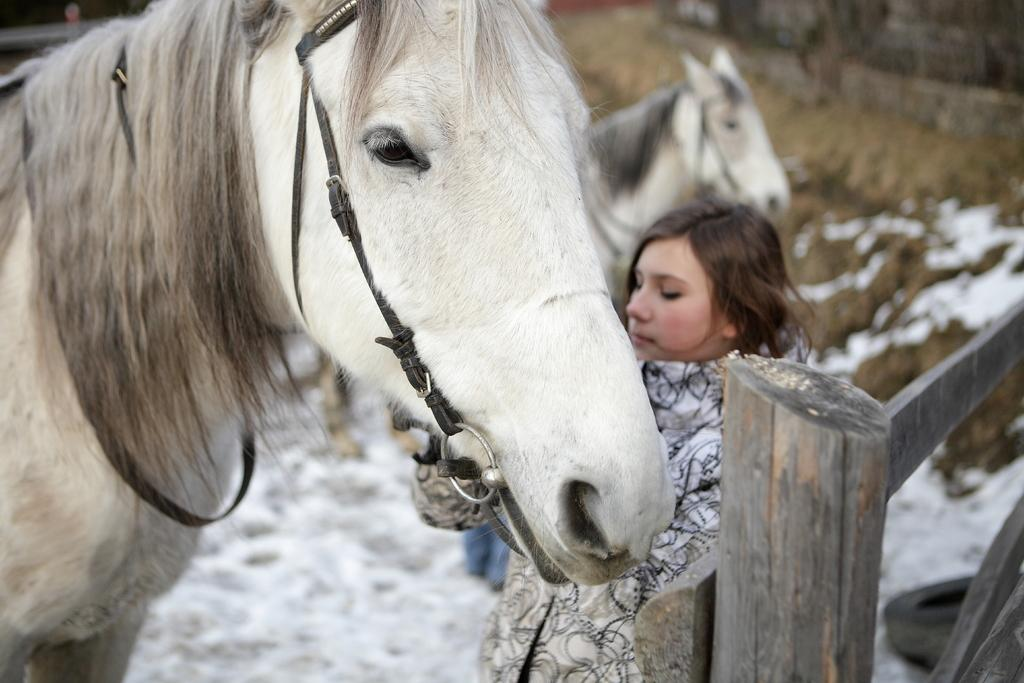Who is present in the image? There is a woman in the image. What animals can be seen in the image? There are two horses in the image. What type of ice can be seen on the branch in the image? There is no ice or branch present in the image; it features a woman and two horses. 